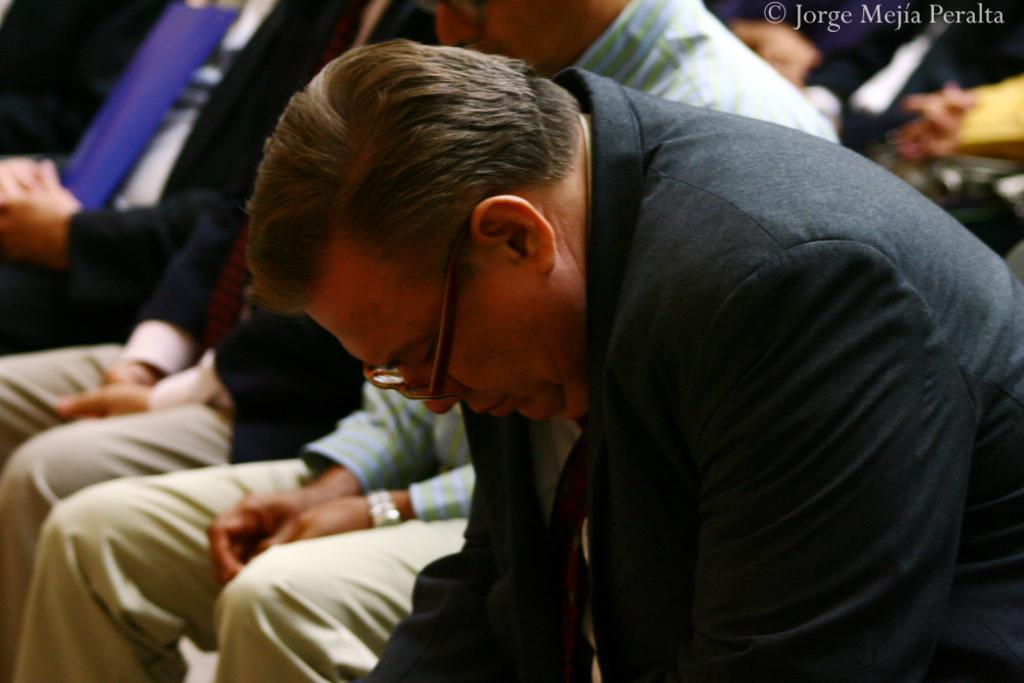How many people are in the image? There are several people in the image. What are the people doing in the image? The people are sitting on chairs and giving condolences. What type of pot is visible in the image? There is no pot present in the image. What kind of teeth can be seen in the image? There are no teeth visible in the image. 